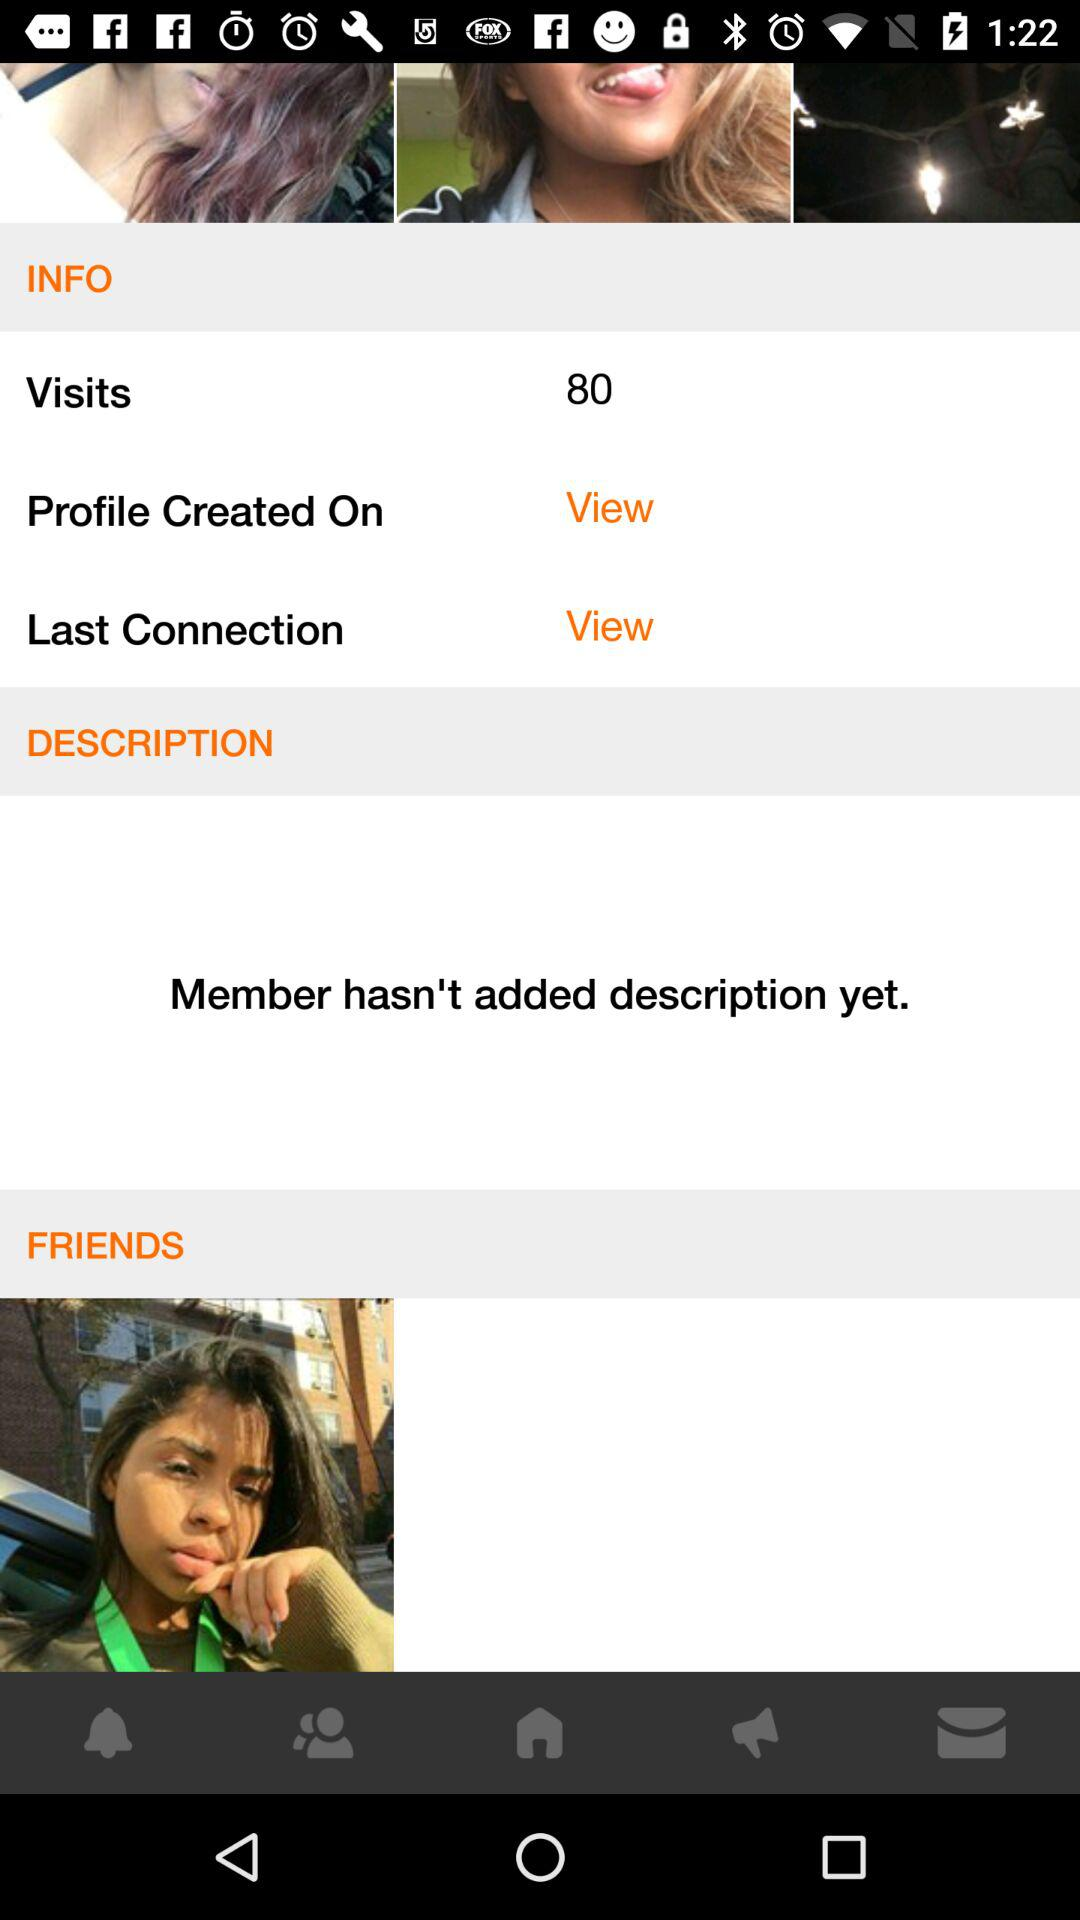How many visits in total are there on the profile? There are 80 visits on the profile. 